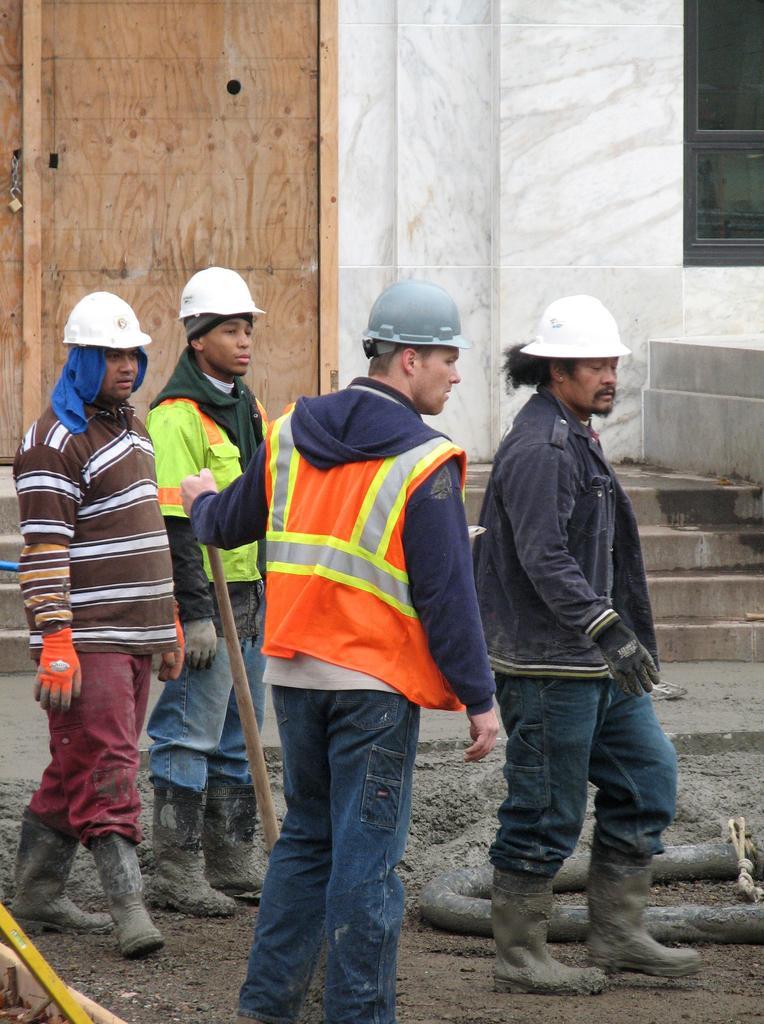Describe this image in one or two sentences. In this image I can see number of persons wearing boots and helmets are standing. I can see a person is holding a wooden stick. In the background I can see a building, a black colored window, few stairs and a brown colored wooden object. 